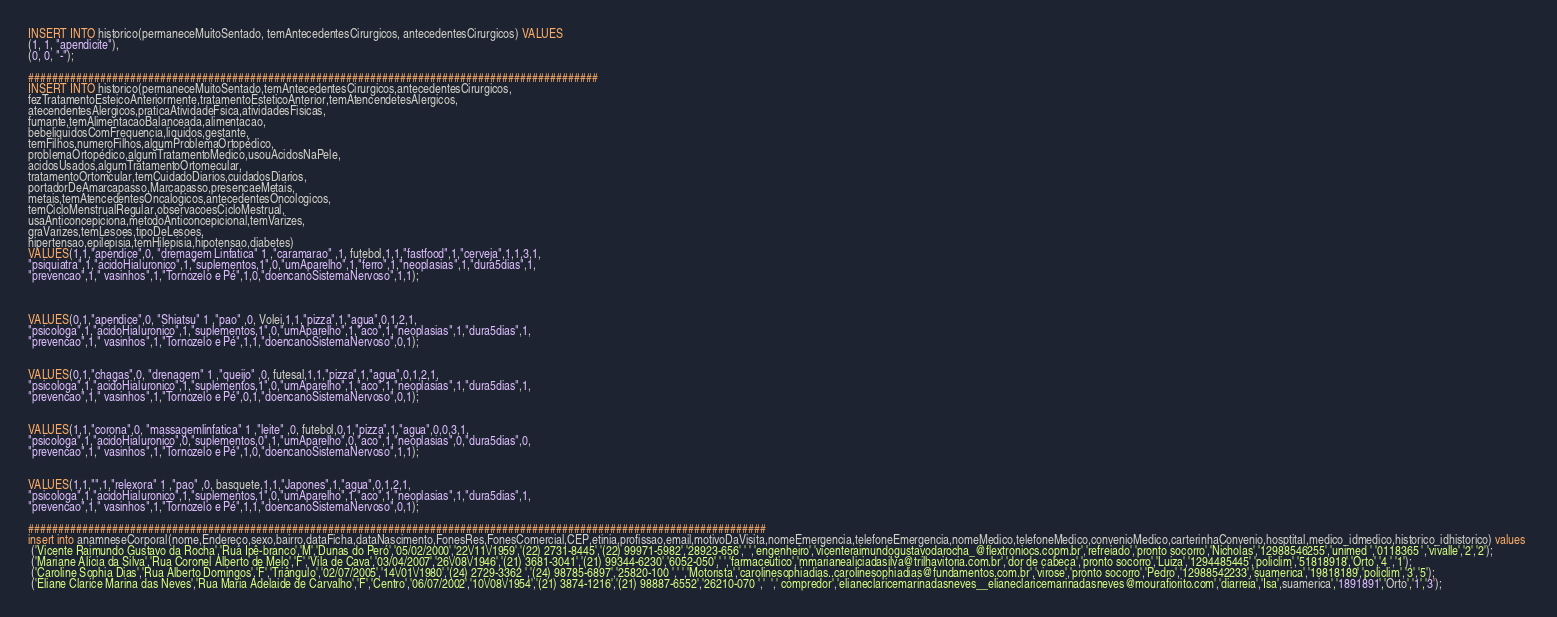Convert code to text. <code><loc_0><loc_0><loc_500><loc_500><_SQL_>INSERT INTO historico(permaneceMuitoSentado, temAntecedentesCirurgicos, antecedentesCirurgicos) VALUES
(1, 1, "apendicite"),
(0, 0, "-");

###############################################################################################
INSERT INTO historico(permaneceMuitoSentado,temAntecedentesCirurgicos,antecedentesCirurgicos,
fezTratamentoEsteicoAnteriormente,tratamentoEsteticoAnterior,temAtencendetesAlergicos,
atecendentesAlergicos,praticaAtividadeFsica,atividadesFisicas,
fumante,temAlimentacaoBalanceada,alimentacao,
bebeliquidosComFrequencia,liquidos,gestante,
temFilhos,numeroFilhos,algumProblemaOrtopédico,
problemaOrtopédico,algumTratamentoMedico,usouAcidosNaPele,
acidosUsados,algumTratamentoOrtomecular,
tratamentoOrtomcular,temCuidadoDiarios,cuidadosDiarios,
portadorDeAmarcapasso,Marcapasso,presencaeMetais,
metais,temAtencedentesOncalogicos,antecedentesOncologicos,
temCicloMenstrualRegular,observacoesCicloMestrual,
usaAnticoncepiciona,metodoAnticoncepicional,temVarizes,
graVarizes,temLesoes,tipoDeLesoes,
hipertensao,epilepisia,temHilepisia,hipotensao,diabetes)
VALUES(1,1,"apendice",0, "dremagem Linfatica" 1 ,"caramarao" ,1, futebol,1,1,"fastfood",1,"cerveja",1,1,3,1,
"psiquiatra",1,"acidoHialuronico",1,"suplementos,1",0,"umAparelho",1,"ferro",1,"neoplasias",1,"dura5dias",1,
"prevencao",1," vasinhos",1,"Tornozelo e Pé",1,0,"doencanoSistemaNervoso",1,1);



VALUES(0,1,"apendice",0, "Shiatsu" 1 ,"pao" ,0, Volei,1,1,"pizza",1,"agua",0,1,2,1,
"psicologa",1,"acidoHialuronico",1,"suplementos,1",0,"umAparelho",1,"aco",1,"neoplasias",1,"dura5dias",1,
"prevencao",1," vasinhos",1,"Tornozelo e Pé",1,1,"doencanoSistemaNervoso",0,1);


VALUES(0,1,"chagas",0, "drenagem" 1 ,"queijo" ,0, futesal,1,1,"pizza",1,"agua",0,1,2,1,
"psicologa",1,"acidoHialuronico",1,"suplementos,1",0,"umAparelho",1,"aco",1,"neoplasias",1,"dura5dias",1,
"prevencao",1," vasinhos",1,"Tornozelo e Pé",0,1,"doencanoSistemaNervoso",0,1);


VALUES(1,1,"corona",0, "massagemlinfatica" 1 ,"leite" ,0, futebol,0,1,"pizza",1,"agua",0,0,3,1,
"psicologa",1,"acidoHialuronico",0,"suplementos,0",1,"umAparelho",0,"aco",1,"neoplasias",0,"dura5dias",0,
"prevencao",1," vasinhos",1,"Tornozelo e Pé",1,0,"doencanoSistemaNervoso",1,1);


VALUES(1,1,"",1,"relexora" 1 ,"pao" ,0, basquete,1,1,"Japones",1,"agua",0,1,2,1,
"psicologa",1,"acidoHialuronico",1,"suplementos,1",0,"umAparelho",1,"aco",1,"neoplasias",1,"dura5dias",1,
"prevencao",1," vasinhos",1,"Tornozelo e Pé",1,1,"doencanoSistemaNervoso",0,1);

###########################################################################################################################
insert into anamneseCorporal(nome,Endereço,sexo,bairro,dataFicha,dataNascimento,FonesRes,FonesComercial,CEP,etinia,profissao,email,motivoDaVisita,nomeEmergencia,telefoneEmergencia,nomeMedico,telefoneMedico,convenioMedico,carterinhaConvenio,hosptital,medico_idmedico,historico_idhistorico) values 
 ('Vicente Raimundo Gustavo da Rocha','Rua Ipê-branco','M','Dunas do Peró','05/02/2000','22\/11\/1959','(22) 2731-8445','(22) 99971-5982','28923-656',' ','engenheiro','vicenteraimundogustavodarocha_@flextroniocs.copm.br','refreiado','pronto socorro','Nicholas','12988546255','unimed ','0118365 ','vivalle','2','2');
 ('Mariane Alícia da Silva','Rua Coronel Alberto de Melo','F','Vila de Cava','03/04/2007','26\/08\/1946','(21) 3681-3041','(21) 99344-6230','6052-050',' ','farmaceutico','mmarianealiciadasilva@trilhavitoria.com.br','dor de cabeca','pronto socorro','Luiza','1294485445','policlim','51818918','Orto','4 ','1');
 ('Caroline Sophia Dias','Rua Alberto Domingos','F','Triângulo','02/07/2005','14\/01\/1980','(24) 2729-3362 ','(24) 98785-6897','25820-100 ',' ','Motorista','carolinesophiadias..carolinesophiadias@fundamentos.com.br','virose','pronto socorro','Pedro','12988542233','suamerica','19818189','policlim','3','5');
 ('Eliane Clarice Marina das Neves','Rua Maria Adelaide de Carvalho','F','Centro','06/07/2002','10\/08\/1954','(21) 3874-1216','(21) 98887-6552','26210-070 ','  ',' compredor','elianeclaricemarinadasneves__elianeclaricemarinadasneves@mourafiorito.com','diarreia','Isa',suamerica','1891891','Orto','1','3');</code> 